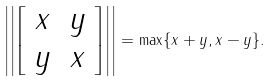<formula> <loc_0><loc_0><loc_500><loc_500>\left | \left | \left [ \begin{array} { c c } x & y \\ y & x \end{array} \right ] \right | \right | = \max \{ \| x + y \| , \| x - y \| \} .</formula> 